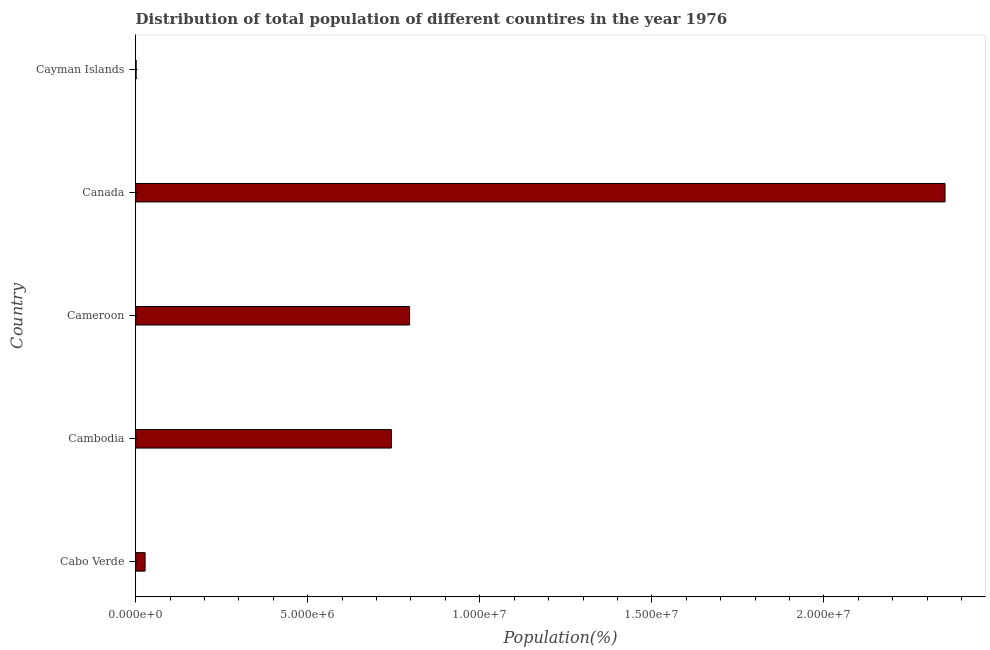What is the title of the graph?
Ensure brevity in your answer.  Distribution of total population of different countires in the year 1976. What is the label or title of the X-axis?
Ensure brevity in your answer.  Population(%). What is the label or title of the Y-axis?
Provide a succinct answer. Country. What is the population in Cameroon?
Ensure brevity in your answer.  7.96e+06. Across all countries, what is the maximum population?
Your answer should be very brief. 2.35e+07. Across all countries, what is the minimum population?
Offer a very short reply. 1.30e+04. In which country was the population minimum?
Make the answer very short. Cayman Islands. What is the sum of the population?
Provide a succinct answer. 3.92e+07. What is the difference between the population in Cameroon and Canada?
Provide a short and direct response. -1.56e+07. What is the average population per country?
Make the answer very short. 7.84e+06. What is the median population?
Your response must be concise. 7.43e+06. In how many countries, is the population greater than 18000000 %?
Ensure brevity in your answer.  1. What is the ratio of the population in Cambodia to that in Cameroon?
Offer a terse response. 0.93. What is the difference between the highest and the second highest population?
Your response must be concise. 1.56e+07. What is the difference between the highest and the lowest population?
Your response must be concise. 2.35e+07. In how many countries, is the population greater than the average population taken over all countries?
Ensure brevity in your answer.  2. How many bars are there?
Your answer should be compact. 5. Are all the bars in the graph horizontal?
Ensure brevity in your answer.  Yes. How many countries are there in the graph?
Offer a terse response. 5. Are the values on the major ticks of X-axis written in scientific E-notation?
Your answer should be very brief. Yes. What is the Population(%) of Cabo Verde?
Provide a short and direct response. 2.74e+05. What is the Population(%) in Cambodia?
Offer a very short reply. 7.43e+06. What is the Population(%) of Cameroon?
Ensure brevity in your answer.  7.96e+06. What is the Population(%) of Canada?
Make the answer very short. 2.35e+07. What is the Population(%) of Cayman Islands?
Ensure brevity in your answer.  1.30e+04. What is the difference between the Population(%) in Cabo Verde and Cambodia?
Your answer should be compact. -7.16e+06. What is the difference between the Population(%) in Cabo Verde and Cameroon?
Give a very brief answer. -7.69e+06. What is the difference between the Population(%) in Cabo Verde and Canada?
Ensure brevity in your answer.  -2.32e+07. What is the difference between the Population(%) in Cabo Verde and Cayman Islands?
Make the answer very short. 2.61e+05. What is the difference between the Population(%) in Cambodia and Cameroon?
Make the answer very short. -5.28e+05. What is the difference between the Population(%) in Cambodia and Canada?
Offer a very short reply. -1.61e+07. What is the difference between the Population(%) in Cambodia and Cayman Islands?
Give a very brief answer. 7.42e+06. What is the difference between the Population(%) in Cameroon and Canada?
Keep it short and to the point. -1.56e+07. What is the difference between the Population(%) in Cameroon and Cayman Islands?
Keep it short and to the point. 7.95e+06. What is the difference between the Population(%) in Canada and Cayman Islands?
Your response must be concise. 2.35e+07. What is the ratio of the Population(%) in Cabo Verde to that in Cambodia?
Offer a terse response. 0.04. What is the ratio of the Population(%) in Cabo Verde to that in Cameroon?
Make the answer very short. 0.03. What is the ratio of the Population(%) in Cabo Verde to that in Canada?
Your answer should be very brief. 0.01. What is the ratio of the Population(%) in Cabo Verde to that in Cayman Islands?
Give a very brief answer. 21.02. What is the ratio of the Population(%) in Cambodia to that in Cameroon?
Provide a succinct answer. 0.93. What is the ratio of the Population(%) in Cambodia to that in Canada?
Keep it short and to the point. 0.32. What is the ratio of the Population(%) in Cambodia to that in Cayman Islands?
Make the answer very short. 570.78. What is the ratio of the Population(%) in Cameroon to that in Canada?
Provide a short and direct response. 0.34. What is the ratio of the Population(%) in Cameroon to that in Cayman Islands?
Make the answer very short. 611.33. What is the ratio of the Population(%) in Canada to that in Cayman Islands?
Your answer should be very brief. 1806.3. 